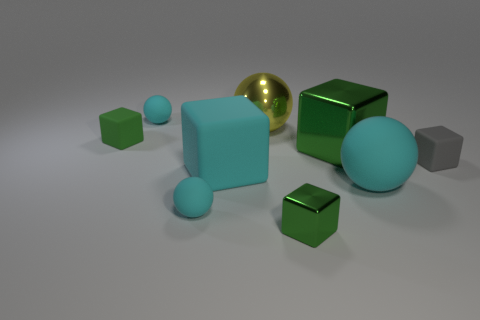Subtract all red cubes. How many cyan balls are left? 3 Subtract 2 blocks. How many blocks are left? 3 Subtract all cyan blocks. How many blocks are left? 4 Subtract all large matte blocks. How many blocks are left? 4 Subtract all blue cubes. Subtract all red cylinders. How many cubes are left? 5 Add 1 tiny cylinders. How many objects exist? 10 Subtract all balls. How many objects are left? 5 Add 4 big cyan rubber blocks. How many big cyan rubber blocks exist? 5 Subtract 0 red cubes. How many objects are left? 9 Subtract all small green matte blocks. Subtract all tiny cyan spheres. How many objects are left? 6 